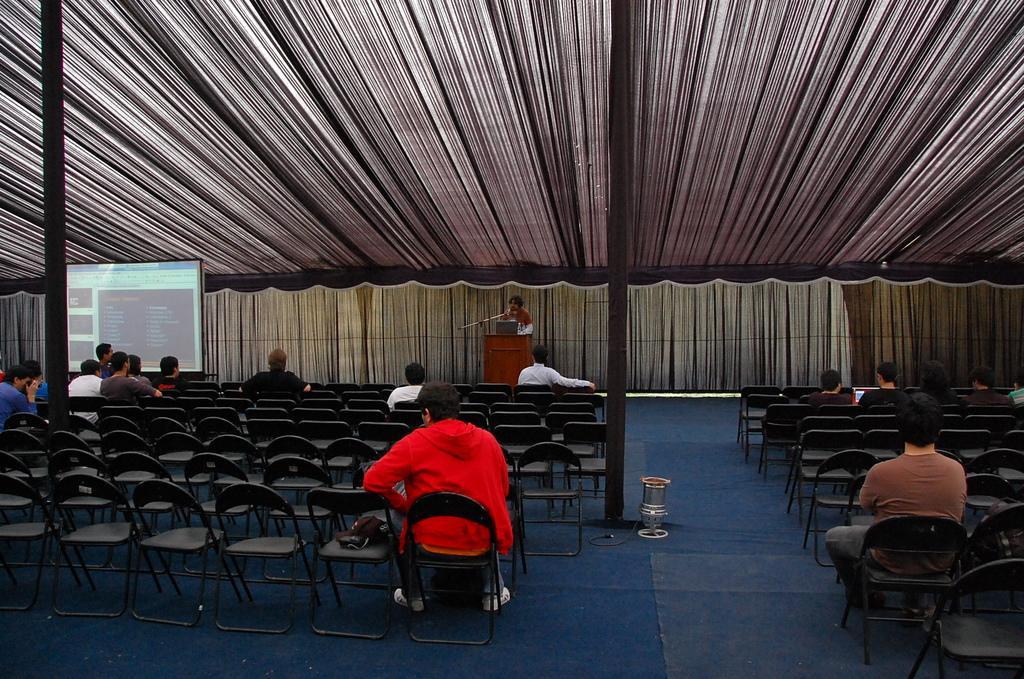Describe this image in one or two sentences. There are few people sitting on the chairs. here is the person standing and speaking. This is a podium with an object on it. At the left side of the image I can see screen. These are the pillars. I think this is the cloth which is at the top. These are the empty chairs. I can see a object placed on the floor. 